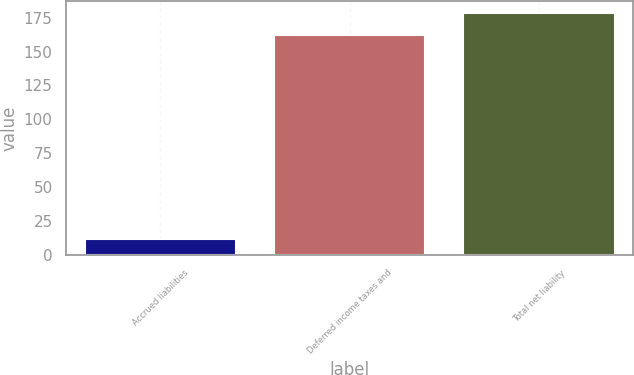Convert chart. <chart><loc_0><loc_0><loc_500><loc_500><bar_chart><fcel>Accrued liabilities<fcel>Deferred income taxes and<fcel>Total net liability<nl><fcel>12<fcel>162<fcel>178.2<nl></chart> 